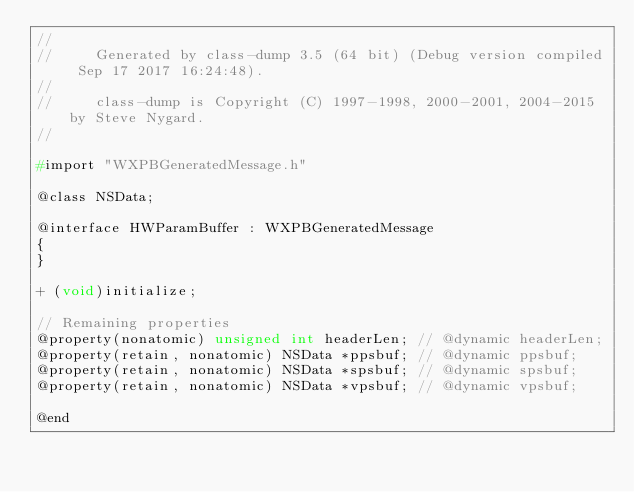<code> <loc_0><loc_0><loc_500><loc_500><_C_>//
//     Generated by class-dump 3.5 (64 bit) (Debug version compiled Sep 17 2017 16:24:48).
//
//     class-dump is Copyright (C) 1997-1998, 2000-2001, 2004-2015 by Steve Nygard.
//

#import "WXPBGeneratedMessage.h"

@class NSData;

@interface HWParamBuffer : WXPBGeneratedMessage
{
}

+ (void)initialize;

// Remaining properties
@property(nonatomic) unsigned int headerLen; // @dynamic headerLen;
@property(retain, nonatomic) NSData *ppsbuf; // @dynamic ppsbuf;
@property(retain, nonatomic) NSData *spsbuf; // @dynamic spsbuf;
@property(retain, nonatomic) NSData *vpsbuf; // @dynamic vpsbuf;

@end

</code> 